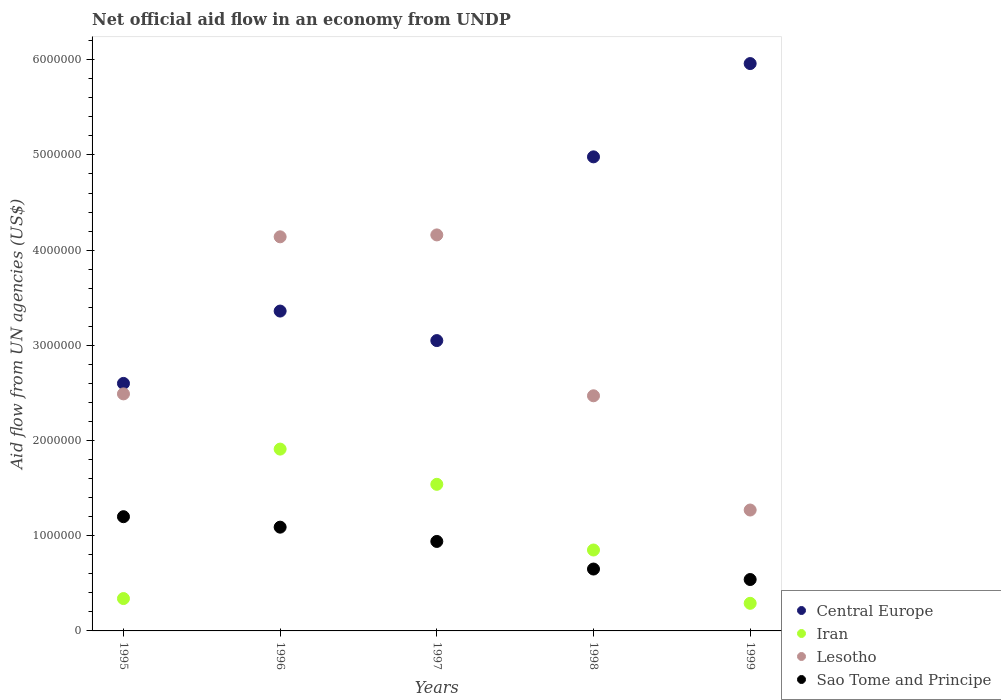What is the net official aid flow in Central Europe in 1998?
Make the answer very short. 4.98e+06. Across all years, what is the maximum net official aid flow in Iran?
Your answer should be compact. 1.91e+06. Across all years, what is the minimum net official aid flow in Lesotho?
Your answer should be compact. 1.27e+06. What is the total net official aid flow in Central Europe in the graph?
Make the answer very short. 2.00e+07. What is the difference between the net official aid flow in Iran in 1995 and that in 1998?
Your answer should be compact. -5.10e+05. What is the difference between the net official aid flow in Iran in 1998 and the net official aid flow in Central Europe in 1997?
Offer a very short reply. -2.20e+06. What is the average net official aid flow in Iran per year?
Provide a succinct answer. 9.86e+05. In the year 1995, what is the difference between the net official aid flow in Central Europe and net official aid flow in Iran?
Make the answer very short. 2.26e+06. In how many years, is the net official aid flow in Lesotho greater than 3400000 US$?
Give a very brief answer. 2. What is the ratio of the net official aid flow in Central Europe in 1996 to that in 1998?
Give a very brief answer. 0.67. Is the net official aid flow in Lesotho in 1995 less than that in 1997?
Offer a terse response. Yes. What is the difference between the highest and the second highest net official aid flow in Lesotho?
Your answer should be very brief. 2.00e+04. What is the difference between the highest and the lowest net official aid flow in Lesotho?
Ensure brevity in your answer.  2.89e+06. Is the sum of the net official aid flow in Lesotho in 1996 and 1997 greater than the maximum net official aid flow in Iran across all years?
Offer a very short reply. Yes. What is the difference between two consecutive major ticks on the Y-axis?
Make the answer very short. 1.00e+06. Does the graph contain any zero values?
Keep it short and to the point. No. Where does the legend appear in the graph?
Provide a succinct answer. Bottom right. What is the title of the graph?
Offer a very short reply. Net official aid flow in an economy from UNDP. What is the label or title of the X-axis?
Make the answer very short. Years. What is the label or title of the Y-axis?
Make the answer very short. Aid flow from UN agencies (US$). What is the Aid flow from UN agencies (US$) in Central Europe in 1995?
Your response must be concise. 2.60e+06. What is the Aid flow from UN agencies (US$) of Iran in 1995?
Your answer should be very brief. 3.40e+05. What is the Aid flow from UN agencies (US$) in Lesotho in 1995?
Offer a terse response. 2.49e+06. What is the Aid flow from UN agencies (US$) in Sao Tome and Principe in 1995?
Your answer should be compact. 1.20e+06. What is the Aid flow from UN agencies (US$) of Central Europe in 1996?
Your answer should be very brief. 3.36e+06. What is the Aid flow from UN agencies (US$) in Iran in 1996?
Provide a short and direct response. 1.91e+06. What is the Aid flow from UN agencies (US$) in Lesotho in 1996?
Provide a short and direct response. 4.14e+06. What is the Aid flow from UN agencies (US$) in Sao Tome and Principe in 1996?
Keep it short and to the point. 1.09e+06. What is the Aid flow from UN agencies (US$) of Central Europe in 1997?
Provide a succinct answer. 3.05e+06. What is the Aid flow from UN agencies (US$) of Iran in 1997?
Give a very brief answer. 1.54e+06. What is the Aid flow from UN agencies (US$) in Lesotho in 1997?
Offer a very short reply. 4.16e+06. What is the Aid flow from UN agencies (US$) in Sao Tome and Principe in 1997?
Offer a very short reply. 9.40e+05. What is the Aid flow from UN agencies (US$) in Central Europe in 1998?
Your answer should be compact. 4.98e+06. What is the Aid flow from UN agencies (US$) of Iran in 1998?
Ensure brevity in your answer.  8.50e+05. What is the Aid flow from UN agencies (US$) of Lesotho in 1998?
Provide a succinct answer. 2.47e+06. What is the Aid flow from UN agencies (US$) of Sao Tome and Principe in 1998?
Offer a terse response. 6.50e+05. What is the Aid flow from UN agencies (US$) in Central Europe in 1999?
Provide a succinct answer. 5.96e+06. What is the Aid flow from UN agencies (US$) of Lesotho in 1999?
Keep it short and to the point. 1.27e+06. What is the Aid flow from UN agencies (US$) of Sao Tome and Principe in 1999?
Offer a terse response. 5.40e+05. Across all years, what is the maximum Aid flow from UN agencies (US$) of Central Europe?
Your answer should be very brief. 5.96e+06. Across all years, what is the maximum Aid flow from UN agencies (US$) in Iran?
Give a very brief answer. 1.91e+06. Across all years, what is the maximum Aid flow from UN agencies (US$) of Lesotho?
Ensure brevity in your answer.  4.16e+06. Across all years, what is the maximum Aid flow from UN agencies (US$) of Sao Tome and Principe?
Keep it short and to the point. 1.20e+06. Across all years, what is the minimum Aid flow from UN agencies (US$) of Central Europe?
Provide a short and direct response. 2.60e+06. Across all years, what is the minimum Aid flow from UN agencies (US$) of Lesotho?
Offer a very short reply. 1.27e+06. Across all years, what is the minimum Aid flow from UN agencies (US$) in Sao Tome and Principe?
Ensure brevity in your answer.  5.40e+05. What is the total Aid flow from UN agencies (US$) of Central Europe in the graph?
Keep it short and to the point. 2.00e+07. What is the total Aid flow from UN agencies (US$) of Iran in the graph?
Your response must be concise. 4.93e+06. What is the total Aid flow from UN agencies (US$) of Lesotho in the graph?
Your answer should be very brief. 1.45e+07. What is the total Aid flow from UN agencies (US$) of Sao Tome and Principe in the graph?
Ensure brevity in your answer.  4.42e+06. What is the difference between the Aid flow from UN agencies (US$) of Central Europe in 1995 and that in 1996?
Give a very brief answer. -7.60e+05. What is the difference between the Aid flow from UN agencies (US$) in Iran in 1995 and that in 1996?
Your answer should be very brief. -1.57e+06. What is the difference between the Aid flow from UN agencies (US$) of Lesotho in 1995 and that in 1996?
Your response must be concise. -1.65e+06. What is the difference between the Aid flow from UN agencies (US$) in Central Europe in 1995 and that in 1997?
Keep it short and to the point. -4.50e+05. What is the difference between the Aid flow from UN agencies (US$) of Iran in 1995 and that in 1997?
Offer a very short reply. -1.20e+06. What is the difference between the Aid flow from UN agencies (US$) in Lesotho in 1995 and that in 1997?
Your answer should be compact. -1.67e+06. What is the difference between the Aid flow from UN agencies (US$) of Sao Tome and Principe in 1995 and that in 1997?
Your answer should be compact. 2.60e+05. What is the difference between the Aid flow from UN agencies (US$) in Central Europe in 1995 and that in 1998?
Your response must be concise. -2.38e+06. What is the difference between the Aid flow from UN agencies (US$) in Iran in 1995 and that in 1998?
Ensure brevity in your answer.  -5.10e+05. What is the difference between the Aid flow from UN agencies (US$) of Lesotho in 1995 and that in 1998?
Your answer should be very brief. 2.00e+04. What is the difference between the Aid flow from UN agencies (US$) of Sao Tome and Principe in 1995 and that in 1998?
Offer a terse response. 5.50e+05. What is the difference between the Aid flow from UN agencies (US$) of Central Europe in 1995 and that in 1999?
Offer a very short reply. -3.36e+06. What is the difference between the Aid flow from UN agencies (US$) of Iran in 1995 and that in 1999?
Keep it short and to the point. 5.00e+04. What is the difference between the Aid flow from UN agencies (US$) of Lesotho in 1995 and that in 1999?
Make the answer very short. 1.22e+06. What is the difference between the Aid flow from UN agencies (US$) of Sao Tome and Principe in 1995 and that in 1999?
Give a very brief answer. 6.60e+05. What is the difference between the Aid flow from UN agencies (US$) of Central Europe in 1996 and that in 1997?
Provide a succinct answer. 3.10e+05. What is the difference between the Aid flow from UN agencies (US$) of Iran in 1996 and that in 1997?
Your answer should be very brief. 3.70e+05. What is the difference between the Aid flow from UN agencies (US$) of Sao Tome and Principe in 1996 and that in 1997?
Your response must be concise. 1.50e+05. What is the difference between the Aid flow from UN agencies (US$) in Central Europe in 1996 and that in 1998?
Offer a very short reply. -1.62e+06. What is the difference between the Aid flow from UN agencies (US$) of Iran in 1996 and that in 1998?
Offer a terse response. 1.06e+06. What is the difference between the Aid flow from UN agencies (US$) in Lesotho in 1996 and that in 1998?
Provide a succinct answer. 1.67e+06. What is the difference between the Aid flow from UN agencies (US$) of Sao Tome and Principe in 1996 and that in 1998?
Your answer should be very brief. 4.40e+05. What is the difference between the Aid flow from UN agencies (US$) of Central Europe in 1996 and that in 1999?
Provide a succinct answer. -2.60e+06. What is the difference between the Aid flow from UN agencies (US$) in Iran in 1996 and that in 1999?
Offer a terse response. 1.62e+06. What is the difference between the Aid flow from UN agencies (US$) in Lesotho in 1996 and that in 1999?
Your answer should be very brief. 2.87e+06. What is the difference between the Aid flow from UN agencies (US$) of Central Europe in 1997 and that in 1998?
Provide a succinct answer. -1.93e+06. What is the difference between the Aid flow from UN agencies (US$) in Iran in 1997 and that in 1998?
Offer a terse response. 6.90e+05. What is the difference between the Aid flow from UN agencies (US$) of Lesotho in 1997 and that in 1998?
Offer a very short reply. 1.69e+06. What is the difference between the Aid flow from UN agencies (US$) in Sao Tome and Principe in 1997 and that in 1998?
Provide a succinct answer. 2.90e+05. What is the difference between the Aid flow from UN agencies (US$) in Central Europe in 1997 and that in 1999?
Give a very brief answer. -2.91e+06. What is the difference between the Aid flow from UN agencies (US$) of Iran in 1997 and that in 1999?
Offer a very short reply. 1.25e+06. What is the difference between the Aid flow from UN agencies (US$) of Lesotho in 1997 and that in 1999?
Make the answer very short. 2.89e+06. What is the difference between the Aid flow from UN agencies (US$) in Central Europe in 1998 and that in 1999?
Give a very brief answer. -9.80e+05. What is the difference between the Aid flow from UN agencies (US$) of Iran in 1998 and that in 1999?
Offer a terse response. 5.60e+05. What is the difference between the Aid flow from UN agencies (US$) of Lesotho in 1998 and that in 1999?
Offer a very short reply. 1.20e+06. What is the difference between the Aid flow from UN agencies (US$) in Sao Tome and Principe in 1998 and that in 1999?
Your answer should be compact. 1.10e+05. What is the difference between the Aid flow from UN agencies (US$) of Central Europe in 1995 and the Aid flow from UN agencies (US$) of Iran in 1996?
Your answer should be very brief. 6.90e+05. What is the difference between the Aid flow from UN agencies (US$) in Central Europe in 1995 and the Aid flow from UN agencies (US$) in Lesotho in 1996?
Ensure brevity in your answer.  -1.54e+06. What is the difference between the Aid flow from UN agencies (US$) of Central Europe in 1995 and the Aid flow from UN agencies (US$) of Sao Tome and Principe in 1996?
Give a very brief answer. 1.51e+06. What is the difference between the Aid flow from UN agencies (US$) of Iran in 1995 and the Aid flow from UN agencies (US$) of Lesotho in 1996?
Offer a very short reply. -3.80e+06. What is the difference between the Aid flow from UN agencies (US$) of Iran in 1995 and the Aid flow from UN agencies (US$) of Sao Tome and Principe in 1996?
Your response must be concise. -7.50e+05. What is the difference between the Aid flow from UN agencies (US$) in Lesotho in 1995 and the Aid flow from UN agencies (US$) in Sao Tome and Principe in 1996?
Your answer should be very brief. 1.40e+06. What is the difference between the Aid flow from UN agencies (US$) of Central Europe in 1995 and the Aid flow from UN agencies (US$) of Iran in 1997?
Provide a succinct answer. 1.06e+06. What is the difference between the Aid flow from UN agencies (US$) in Central Europe in 1995 and the Aid flow from UN agencies (US$) in Lesotho in 1997?
Provide a short and direct response. -1.56e+06. What is the difference between the Aid flow from UN agencies (US$) of Central Europe in 1995 and the Aid flow from UN agencies (US$) of Sao Tome and Principe in 1997?
Give a very brief answer. 1.66e+06. What is the difference between the Aid flow from UN agencies (US$) in Iran in 1995 and the Aid flow from UN agencies (US$) in Lesotho in 1997?
Offer a very short reply. -3.82e+06. What is the difference between the Aid flow from UN agencies (US$) of Iran in 1995 and the Aid flow from UN agencies (US$) of Sao Tome and Principe in 1997?
Provide a succinct answer. -6.00e+05. What is the difference between the Aid flow from UN agencies (US$) of Lesotho in 1995 and the Aid flow from UN agencies (US$) of Sao Tome and Principe in 1997?
Provide a short and direct response. 1.55e+06. What is the difference between the Aid flow from UN agencies (US$) in Central Europe in 1995 and the Aid flow from UN agencies (US$) in Iran in 1998?
Make the answer very short. 1.75e+06. What is the difference between the Aid flow from UN agencies (US$) of Central Europe in 1995 and the Aid flow from UN agencies (US$) of Lesotho in 1998?
Make the answer very short. 1.30e+05. What is the difference between the Aid flow from UN agencies (US$) in Central Europe in 1995 and the Aid flow from UN agencies (US$) in Sao Tome and Principe in 1998?
Provide a short and direct response. 1.95e+06. What is the difference between the Aid flow from UN agencies (US$) in Iran in 1995 and the Aid flow from UN agencies (US$) in Lesotho in 1998?
Your answer should be compact. -2.13e+06. What is the difference between the Aid flow from UN agencies (US$) of Iran in 1995 and the Aid flow from UN agencies (US$) of Sao Tome and Principe in 1998?
Your answer should be compact. -3.10e+05. What is the difference between the Aid flow from UN agencies (US$) in Lesotho in 1995 and the Aid flow from UN agencies (US$) in Sao Tome and Principe in 1998?
Offer a very short reply. 1.84e+06. What is the difference between the Aid flow from UN agencies (US$) of Central Europe in 1995 and the Aid flow from UN agencies (US$) of Iran in 1999?
Your answer should be very brief. 2.31e+06. What is the difference between the Aid flow from UN agencies (US$) of Central Europe in 1995 and the Aid flow from UN agencies (US$) of Lesotho in 1999?
Provide a short and direct response. 1.33e+06. What is the difference between the Aid flow from UN agencies (US$) of Central Europe in 1995 and the Aid flow from UN agencies (US$) of Sao Tome and Principe in 1999?
Offer a terse response. 2.06e+06. What is the difference between the Aid flow from UN agencies (US$) in Iran in 1995 and the Aid flow from UN agencies (US$) in Lesotho in 1999?
Give a very brief answer. -9.30e+05. What is the difference between the Aid flow from UN agencies (US$) in Lesotho in 1995 and the Aid flow from UN agencies (US$) in Sao Tome and Principe in 1999?
Give a very brief answer. 1.95e+06. What is the difference between the Aid flow from UN agencies (US$) in Central Europe in 1996 and the Aid flow from UN agencies (US$) in Iran in 1997?
Keep it short and to the point. 1.82e+06. What is the difference between the Aid flow from UN agencies (US$) in Central Europe in 1996 and the Aid flow from UN agencies (US$) in Lesotho in 1997?
Your response must be concise. -8.00e+05. What is the difference between the Aid flow from UN agencies (US$) of Central Europe in 1996 and the Aid flow from UN agencies (US$) of Sao Tome and Principe in 1997?
Your answer should be compact. 2.42e+06. What is the difference between the Aid flow from UN agencies (US$) in Iran in 1996 and the Aid flow from UN agencies (US$) in Lesotho in 1997?
Offer a very short reply. -2.25e+06. What is the difference between the Aid flow from UN agencies (US$) in Iran in 1996 and the Aid flow from UN agencies (US$) in Sao Tome and Principe in 1997?
Provide a succinct answer. 9.70e+05. What is the difference between the Aid flow from UN agencies (US$) in Lesotho in 1996 and the Aid flow from UN agencies (US$) in Sao Tome and Principe in 1997?
Give a very brief answer. 3.20e+06. What is the difference between the Aid flow from UN agencies (US$) of Central Europe in 1996 and the Aid flow from UN agencies (US$) of Iran in 1998?
Provide a short and direct response. 2.51e+06. What is the difference between the Aid flow from UN agencies (US$) of Central Europe in 1996 and the Aid flow from UN agencies (US$) of Lesotho in 1998?
Your answer should be very brief. 8.90e+05. What is the difference between the Aid flow from UN agencies (US$) in Central Europe in 1996 and the Aid flow from UN agencies (US$) in Sao Tome and Principe in 1998?
Your answer should be very brief. 2.71e+06. What is the difference between the Aid flow from UN agencies (US$) in Iran in 1996 and the Aid flow from UN agencies (US$) in Lesotho in 1998?
Your response must be concise. -5.60e+05. What is the difference between the Aid flow from UN agencies (US$) in Iran in 1996 and the Aid flow from UN agencies (US$) in Sao Tome and Principe in 1998?
Give a very brief answer. 1.26e+06. What is the difference between the Aid flow from UN agencies (US$) in Lesotho in 1996 and the Aid flow from UN agencies (US$) in Sao Tome and Principe in 1998?
Keep it short and to the point. 3.49e+06. What is the difference between the Aid flow from UN agencies (US$) of Central Europe in 1996 and the Aid flow from UN agencies (US$) of Iran in 1999?
Ensure brevity in your answer.  3.07e+06. What is the difference between the Aid flow from UN agencies (US$) in Central Europe in 1996 and the Aid flow from UN agencies (US$) in Lesotho in 1999?
Provide a succinct answer. 2.09e+06. What is the difference between the Aid flow from UN agencies (US$) of Central Europe in 1996 and the Aid flow from UN agencies (US$) of Sao Tome and Principe in 1999?
Ensure brevity in your answer.  2.82e+06. What is the difference between the Aid flow from UN agencies (US$) of Iran in 1996 and the Aid flow from UN agencies (US$) of Lesotho in 1999?
Provide a short and direct response. 6.40e+05. What is the difference between the Aid flow from UN agencies (US$) in Iran in 1996 and the Aid flow from UN agencies (US$) in Sao Tome and Principe in 1999?
Offer a very short reply. 1.37e+06. What is the difference between the Aid flow from UN agencies (US$) in Lesotho in 1996 and the Aid flow from UN agencies (US$) in Sao Tome and Principe in 1999?
Provide a short and direct response. 3.60e+06. What is the difference between the Aid flow from UN agencies (US$) in Central Europe in 1997 and the Aid flow from UN agencies (US$) in Iran in 1998?
Give a very brief answer. 2.20e+06. What is the difference between the Aid flow from UN agencies (US$) of Central Europe in 1997 and the Aid flow from UN agencies (US$) of Lesotho in 1998?
Provide a succinct answer. 5.80e+05. What is the difference between the Aid flow from UN agencies (US$) in Central Europe in 1997 and the Aid flow from UN agencies (US$) in Sao Tome and Principe in 1998?
Keep it short and to the point. 2.40e+06. What is the difference between the Aid flow from UN agencies (US$) in Iran in 1997 and the Aid flow from UN agencies (US$) in Lesotho in 1998?
Provide a short and direct response. -9.30e+05. What is the difference between the Aid flow from UN agencies (US$) of Iran in 1997 and the Aid flow from UN agencies (US$) of Sao Tome and Principe in 1998?
Your answer should be very brief. 8.90e+05. What is the difference between the Aid flow from UN agencies (US$) in Lesotho in 1997 and the Aid flow from UN agencies (US$) in Sao Tome and Principe in 1998?
Give a very brief answer. 3.51e+06. What is the difference between the Aid flow from UN agencies (US$) in Central Europe in 1997 and the Aid flow from UN agencies (US$) in Iran in 1999?
Your response must be concise. 2.76e+06. What is the difference between the Aid flow from UN agencies (US$) of Central Europe in 1997 and the Aid flow from UN agencies (US$) of Lesotho in 1999?
Provide a succinct answer. 1.78e+06. What is the difference between the Aid flow from UN agencies (US$) in Central Europe in 1997 and the Aid flow from UN agencies (US$) in Sao Tome and Principe in 1999?
Keep it short and to the point. 2.51e+06. What is the difference between the Aid flow from UN agencies (US$) in Iran in 1997 and the Aid flow from UN agencies (US$) in Lesotho in 1999?
Make the answer very short. 2.70e+05. What is the difference between the Aid flow from UN agencies (US$) of Lesotho in 1997 and the Aid flow from UN agencies (US$) of Sao Tome and Principe in 1999?
Provide a succinct answer. 3.62e+06. What is the difference between the Aid flow from UN agencies (US$) in Central Europe in 1998 and the Aid flow from UN agencies (US$) in Iran in 1999?
Make the answer very short. 4.69e+06. What is the difference between the Aid flow from UN agencies (US$) of Central Europe in 1998 and the Aid flow from UN agencies (US$) of Lesotho in 1999?
Keep it short and to the point. 3.71e+06. What is the difference between the Aid flow from UN agencies (US$) in Central Europe in 1998 and the Aid flow from UN agencies (US$) in Sao Tome and Principe in 1999?
Give a very brief answer. 4.44e+06. What is the difference between the Aid flow from UN agencies (US$) in Iran in 1998 and the Aid flow from UN agencies (US$) in Lesotho in 1999?
Provide a succinct answer. -4.20e+05. What is the difference between the Aid flow from UN agencies (US$) in Iran in 1998 and the Aid flow from UN agencies (US$) in Sao Tome and Principe in 1999?
Give a very brief answer. 3.10e+05. What is the difference between the Aid flow from UN agencies (US$) in Lesotho in 1998 and the Aid flow from UN agencies (US$) in Sao Tome and Principe in 1999?
Offer a terse response. 1.93e+06. What is the average Aid flow from UN agencies (US$) of Central Europe per year?
Your answer should be compact. 3.99e+06. What is the average Aid flow from UN agencies (US$) in Iran per year?
Ensure brevity in your answer.  9.86e+05. What is the average Aid flow from UN agencies (US$) of Lesotho per year?
Provide a succinct answer. 2.91e+06. What is the average Aid flow from UN agencies (US$) of Sao Tome and Principe per year?
Give a very brief answer. 8.84e+05. In the year 1995, what is the difference between the Aid flow from UN agencies (US$) of Central Europe and Aid flow from UN agencies (US$) of Iran?
Your response must be concise. 2.26e+06. In the year 1995, what is the difference between the Aid flow from UN agencies (US$) of Central Europe and Aid flow from UN agencies (US$) of Lesotho?
Your answer should be very brief. 1.10e+05. In the year 1995, what is the difference between the Aid flow from UN agencies (US$) of Central Europe and Aid flow from UN agencies (US$) of Sao Tome and Principe?
Offer a terse response. 1.40e+06. In the year 1995, what is the difference between the Aid flow from UN agencies (US$) in Iran and Aid flow from UN agencies (US$) in Lesotho?
Your answer should be compact. -2.15e+06. In the year 1995, what is the difference between the Aid flow from UN agencies (US$) in Iran and Aid flow from UN agencies (US$) in Sao Tome and Principe?
Provide a short and direct response. -8.60e+05. In the year 1995, what is the difference between the Aid flow from UN agencies (US$) in Lesotho and Aid flow from UN agencies (US$) in Sao Tome and Principe?
Your answer should be compact. 1.29e+06. In the year 1996, what is the difference between the Aid flow from UN agencies (US$) in Central Europe and Aid flow from UN agencies (US$) in Iran?
Make the answer very short. 1.45e+06. In the year 1996, what is the difference between the Aid flow from UN agencies (US$) of Central Europe and Aid flow from UN agencies (US$) of Lesotho?
Provide a succinct answer. -7.80e+05. In the year 1996, what is the difference between the Aid flow from UN agencies (US$) of Central Europe and Aid flow from UN agencies (US$) of Sao Tome and Principe?
Offer a terse response. 2.27e+06. In the year 1996, what is the difference between the Aid flow from UN agencies (US$) of Iran and Aid flow from UN agencies (US$) of Lesotho?
Your answer should be compact. -2.23e+06. In the year 1996, what is the difference between the Aid flow from UN agencies (US$) of Iran and Aid flow from UN agencies (US$) of Sao Tome and Principe?
Offer a terse response. 8.20e+05. In the year 1996, what is the difference between the Aid flow from UN agencies (US$) of Lesotho and Aid flow from UN agencies (US$) of Sao Tome and Principe?
Make the answer very short. 3.05e+06. In the year 1997, what is the difference between the Aid flow from UN agencies (US$) in Central Europe and Aid flow from UN agencies (US$) in Iran?
Ensure brevity in your answer.  1.51e+06. In the year 1997, what is the difference between the Aid flow from UN agencies (US$) of Central Europe and Aid flow from UN agencies (US$) of Lesotho?
Give a very brief answer. -1.11e+06. In the year 1997, what is the difference between the Aid flow from UN agencies (US$) in Central Europe and Aid flow from UN agencies (US$) in Sao Tome and Principe?
Offer a very short reply. 2.11e+06. In the year 1997, what is the difference between the Aid flow from UN agencies (US$) of Iran and Aid flow from UN agencies (US$) of Lesotho?
Ensure brevity in your answer.  -2.62e+06. In the year 1997, what is the difference between the Aid flow from UN agencies (US$) of Lesotho and Aid flow from UN agencies (US$) of Sao Tome and Principe?
Offer a very short reply. 3.22e+06. In the year 1998, what is the difference between the Aid flow from UN agencies (US$) in Central Europe and Aid flow from UN agencies (US$) in Iran?
Your answer should be compact. 4.13e+06. In the year 1998, what is the difference between the Aid flow from UN agencies (US$) of Central Europe and Aid flow from UN agencies (US$) of Lesotho?
Provide a succinct answer. 2.51e+06. In the year 1998, what is the difference between the Aid flow from UN agencies (US$) in Central Europe and Aid flow from UN agencies (US$) in Sao Tome and Principe?
Offer a very short reply. 4.33e+06. In the year 1998, what is the difference between the Aid flow from UN agencies (US$) in Iran and Aid flow from UN agencies (US$) in Lesotho?
Offer a terse response. -1.62e+06. In the year 1998, what is the difference between the Aid flow from UN agencies (US$) in Iran and Aid flow from UN agencies (US$) in Sao Tome and Principe?
Offer a terse response. 2.00e+05. In the year 1998, what is the difference between the Aid flow from UN agencies (US$) in Lesotho and Aid flow from UN agencies (US$) in Sao Tome and Principe?
Your answer should be compact. 1.82e+06. In the year 1999, what is the difference between the Aid flow from UN agencies (US$) of Central Europe and Aid flow from UN agencies (US$) of Iran?
Provide a succinct answer. 5.67e+06. In the year 1999, what is the difference between the Aid flow from UN agencies (US$) in Central Europe and Aid flow from UN agencies (US$) in Lesotho?
Give a very brief answer. 4.69e+06. In the year 1999, what is the difference between the Aid flow from UN agencies (US$) of Central Europe and Aid flow from UN agencies (US$) of Sao Tome and Principe?
Give a very brief answer. 5.42e+06. In the year 1999, what is the difference between the Aid flow from UN agencies (US$) of Iran and Aid flow from UN agencies (US$) of Lesotho?
Offer a very short reply. -9.80e+05. In the year 1999, what is the difference between the Aid flow from UN agencies (US$) of Iran and Aid flow from UN agencies (US$) of Sao Tome and Principe?
Your answer should be very brief. -2.50e+05. In the year 1999, what is the difference between the Aid flow from UN agencies (US$) of Lesotho and Aid flow from UN agencies (US$) of Sao Tome and Principe?
Your answer should be very brief. 7.30e+05. What is the ratio of the Aid flow from UN agencies (US$) in Central Europe in 1995 to that in 1996?
Your response must be concise. 0.77. What is the ratio of the Aid flow from UN agencies (US$) of Iran in 1995 to that in 1996?
Give a very brief answer. 0.18. What is the ratio of the Aid flow from UN agencies (US$) of Lesotho in 1995 to that in 1996?
Your response must be concise. 0.6. What is the ratio of the Aid flow from UN agencies (US$) in Sao Tome and Principe in 1995 to that in 1996?
Your response must be concise. 1.1. What is the ratio of the Aid flow from UN agencies (US$) in Central Europe in 1995 to that in 1997?
Your answer should be very brief. 0.85. What is the ratio of the Aid flow from UN agencies (US$) in Iran in 1995 to that in 1997?
Give a very brief answer. 0.22. What is the ratio of the Aid flow from UN agencies (US$) of Lesotho in 1995 to that in 1997?
Make the answer very short. 0.6. What is the ratio of the Aid flow from UN agencies (US$) of Sao Tome and Principe in 1995 to that in 1997?
Offer a terse response. 1.28. What is the ratio of the Aid flow from UN agencies (US$) in Central Europe in 1995 to that in 1998?
Your response must be concise. 0.52. What is the ratio of the Aid flow from UN agencies (US$) of Lesotho in 1995 to that in 1998?
Your answer should be very brief. 1.01. What is the ratio of the Aid flow from UN agencies (US$) in Sao Tome and Principe in 1995 to that in 1998?
Make the answer very short. 1.85. What is the ratio of the Aid flow from UN agencies (US$) of Central Europe in 1995 to that in 1999?
Give a very brief answer. 0.44. What is the ratio of the Aid flow from UN agencies (US$) in Iran in 1995 to that in 1999?
Give a very brief answer. 1.17. What is the ratio of the Aid flow from UN agencies (US$) in Lesotho in 1995 to that in 1999?
Provide a short and direct response. 1.96. What is the ratio of the Aid flow from UN agencies (US$) of Sao Tome and Principe in 1995 to that in 1999?
Offer a terse response. 2.22. What is the ratio of the Aid flow from UN agencies (US$) of Central Europe in 1996 to that in 1997?
Provide a succinct answer. 1.1. What is the ratio of the Aid flow from UN agencies (US$) of Iran in 1996 to that in 1997?
Provide a short and direct response. 1.24. What is the ratio of the Aid flow from UN agencies (US$) in Sao Tome and Principe in 1996 to that in 1997?
Offer a terse response. 1.16. What is the ratio of the Aid flow from UN agencies (US$) of Central Europe in 1996 to that in 1998?
Ensure brevity in your answer.  0.67. What is the ratio of the Aid flow from UN agencies (US$) in Iran in 1996 to that in 1998?
Offer a very short reply. 2.25. What is the ratio of the Aid flow from UN agencies (US$) of Lesotho in 1996 to that in 1998?
Your response must be concise. 1.68. What is the ratio of the Aid flow from UN agencies (US$) of Sao Tome and Principe in 1996 to that in 1998?
Ensure brevity in your answer.  1.68. What is the ratio of the Aid flow from UN agencies (US$) of Central Europe in 1996 to that in 1999?
Your response must be concise. 0.56. What is the ratio of the Aid flow from UN agencies (US$) of Iran in 1996 to that in 1999?
Your answer should be very brief. 6.59. What is the ratio of the Aid flow from UN agencies (US$) in Lesotho in 1996 to that in 1999?
Give a very brief answer. 3.26. What is the ratio of the Aid flow from UN agencies (US$) of Sao Tome and Principe in 1996 to that in 1999?
Provide a short and direct response. 2.02. What is the ratio of the Aid flow from UN agencies (US$) of Central Europe in 1997 to that in 1998?
Offer a terse response. 0.61. What is the ratio of the Aid flow from UN agencies (US$) in Iran in 1997 to that in 1998?
Provide a succinct answer. 1.81. What is the ratio of the Aid flow from UN agencies (US$) in Lesotho in 1997 to that in 1998?
Give a very brief answer. 1.68. What is the ratio of the Aid flow from UN agencies (US$) in Sao Tome and Principe in 1997 to that in 1998?
Your answer should be very brief. 1.45. What is the ratio of the Aid flow from UN agencies (US$) of Central Europe in 1997 to that in 1999?
Offer a very short reply. 0.51. What is the ratio of the Aid flow from UN agencies (US$) of Iran in 1997 to that in 1999?
Keep it short and to the point. 5.31. What is the ratio of the Aid flow from UN agencies (US$) in Lesotho in 1997 to that in 1999?
Provide a short and direct response. 3.28. What is the ratio of the Aid flow from UN agencies (US$) of Sao Tome and Principe in 1997 to that in 1999?
Your answer should be compact. 1.74. What is the ratio of the Aid flow from UN agencies (US$) of Central Europe in 1998 to that in 1999?
Provide a short and direct response. 0.84. What is the ratio of the Aid flow from UN agencies (US$) of Iran in 1998 to that in 1999?
Provide a succinct answer. 2.93. What is the ratio of the Aid flow from UN agencies (US$) in Lesotho in 1998 to that in 1999?
Your answer should be very brief. 1.94. What is the ratio of the Aid flow from UN agencies (US$) of Sao Tome and Principe in 1998 to that in 1999?
Your answer should be compact. 1.2. What is the difference between the highest and the second highest Aid flow from UN agencies (US$) of Central Europe?
Your answer should be very brief. 9.80e+05. What is the difference between the highest and the second highest Aid flow from UN agencies (US$) of Iran?
Make the answer very short. 3.70e+05. What is the difference between the highest and the second highest Aid flow from UN agencies (US$) in Sao Tome and Principe?
Keep it short and to the point. 1.10e+05. What is the difference between the highest and the lowest Aid flow from UN agencies (US$) of Central Europe?
Keep it short and to the point. 3.36e+06. What is the difference between the highest and the lowest Aid flow from UN agencies (US$) in Iran?
Your response must be concise. 1.62e+06. What is the difference between the highest and the lowest Aid flow from UN agencies (US$) in Lesotho?
Provide a succinct answer. 2.89e+06. What is the difference between the highest and the lowest Aid flow from UN agencies (US$) in Sao Tome and Principe?
Make the answer very short. 6.60e+05. 